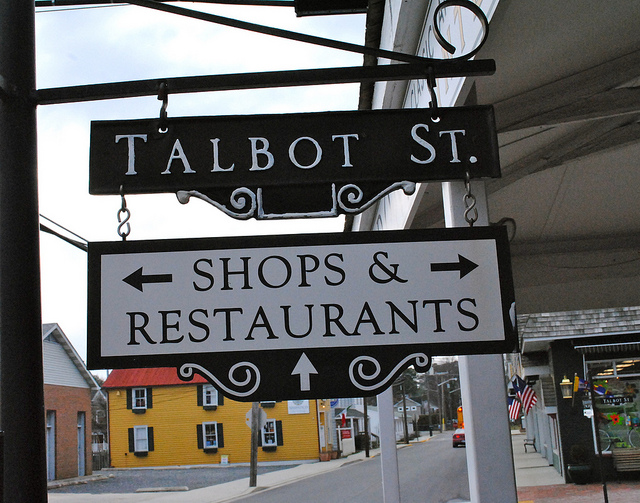How many bedrooms are for rent? The image does not provide any information about bedrooms for rent as it is a street sign indicating the direction to 'Shops & Restaurants' on 'Talbot St.' without any visible listings or advertisements for rentals. 